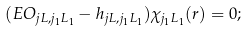Convert formula to latex. <formula><loc_0><loc_0><loc_500><loc_500>( E O _ { j L , j _ { 1 } L _ { 1 } } - h _ { j L , j _ { 1 } L _ { 1 } } ) \chi _ { j _ { 1 } L _ { 1 } } ( r ) = 0 ;</formula> 